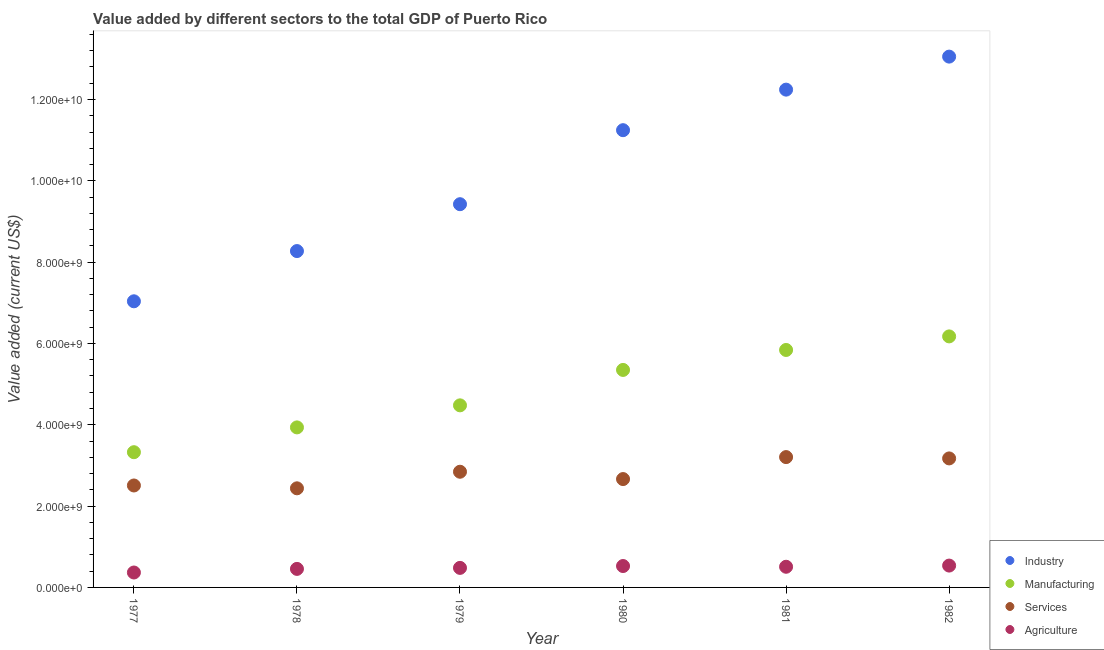What is the value added by services sector in 1979?
Keep it short and to the point. 2.84e+09. Across all years, what is the maximum value added by manufacturing sector?
Keep it short and to the point. 6.17e+09. Across all years, what is the minimum value added by services sector?
Your answer should be compact. 2.44e+09. In which year was the value added by manufacturing sector maximum?
Offer a terse response. 1982. In which year was the value added by industrial sector minimum?
Provide a succinct answer. 1977. What is the total value added by services sector in the graph?
Offer a very short reply. 1.68e+1. What is the difference between the value added by services sector in 1977 and that in 1982?
Your answer should be very brief. -6.66e+08. What is the difference between the value added by manufacturing sector in 1981 and the value added by services sector in 1977?
Offer a very short reply. 3.33e+09. What is the average value added by agricultural sector per year?
Offer a terse response. 4.79e+08. In the year 1978, what is the difference between the value added by industrial sector and value added by agricultural sector?
Provide a succinct answer. 7.82e+09. What is the ratio of the value added by manufacturing sector in 1978 to that in 1982?
Provide a succinct answer. 0.64. What is the difference between the highest and the second highest value added by services sector?
Ensure brevity in your answer.  3.25e+07. What is the difference between the highest and the lowest value added by services sector?
Ensure brevity in your answer.  7.68e+08. In how many years, is the value added by industrial sector greater than the average value added by industrial sector taken over all years?
Offer a terse response. 3. Is the value added by agricultural sector strictly less than the value added by manufacturing sector over the years?
Your answer should be compact. Yes. How many dotlines are there?
Your answer should be compact. 4. Are the values on the major ticks of Y-axis written in scientific E-notation?
Offer a very short reply. Yes. Does the graph contain any zero values?
Offer a terse response. No. Does the graph contain grids?
Keep it short and to the point. No. How are the legend labels stacked?
Give a very brief answer. Vertical. What is the title of the graph?
Provide a succinct answer. Value added by different sectors to the total GDP of Puerto Rico. Does "Corruption" appear as one of the legend labels in the graph?
Provide a succinct answer. No. What is the label or title of the Y-axis?
Offer a terse response. Value added (current US$). What is the Value added (current US$) of Industry in 1977?
Offer a very short reply. 7.04e+09. What is the Value added (current US$) of Manufacturing in 1977?
Your answer should be compact. 3.33e+09. What is the Value added (current US$) of Services in 1977?
Offer a very short reply. 2.51e+09. What is the Value added (current US$) in Agriculture in 1977?
Ensure brevity in your answer.  3.67e+08. What is the Value added (current US$) in Industry in 1978?
Offer a very short reply. 8.27e+09. What is the Value added (current US$) in Manufacturing in 1978?
Give a very brief answer. 3.94e+09. What is the Value added (current US$) in Services in 1978?
Your answer should be compact. 2.44e+09. What is the Value added (current US$) of Agriculture in 1978?
Your response must be concise. 4.56e+08. What is the Value added (current US$) in Industry in 1979?
Make the answer very short. 9.42e+09. What is the Value added (current US$) in Manufacturing in 1979?
Provide a short and direct response. 4.48e+09. What is the Value added (current US$) in Services in 1979?
Your answer should be compact. 2.84e+09. What is the Value added (current US$) in Agriculture in 1979?
Ensure brevity in your answer.  4.81e+08. What is the Value added (current US$) of Industry in 1980?
Make the answer very short. 1.12e+1. What is the Value added (current US$) in Manufacturing in 1980?
Keep it short and to the point. 5.35e+09. What is the Value added (current US$) of Services in 1980?
Provide a short and direct response. 2.66e+09. What is the Value added (current US$) of Agriculture in 1980?
Your response must be concise. 5.26e+08. What is the Value added (current US$) in Industry in 1981?
Keep it short and to the point. 1.22e+1. What is the Value added (current US$) of Manufacturing in 1981?
Your answer should be very brief. 5.84e+09. What is the Value added (current US$) of Services in 1981?
Provide a succinct answer. 3.21e+09. What is the Value added (current US$) in Agriculture in 1981?
Ensure brevity in your answer.  5.08e+08. What is the Value added (current US$) of Industry in 1982?
Offer a terse response. 1.31e+1. What is the Value added (current US$) in Manufacturing in 1982?
Ensure brevity in your answer.  6.17e+09. What is the Value added (current US$) in Services in 1982?
Your answer should be compact. 3.17e+09. What is the Value added (current US$) of Agriculture in 1982?
Offer a very short reply. 5.37e+08. Across all years, what is the maximum Value added (current US$) in Industry?
Ensure brevity in your answer.  1.31e+1. Across all years, what is the maximum Value added (current US$) in Manufacturing?
Provide a succinct answer. 6.17e+09. Across all years, what is the maximum Value added (current US$) of Services?
Offer a terse response. 3.21e+09. Across all years, what is the maximum Value added (current US$) of Agriculture?
Make the answer very short. 5.37e+08. Across all years, what is the minimum Value added (current US$) of Industry?
Offer a very short reply. 7.04e+09. Across all years, what is the minimum Value added (current US$) of Manufacturing?
Offer a terse response. 3.33e+09. Across all years, what is the minimum Value added (current US$) of Services?
Your answer should be very brief. 2.44e+09. Across all years, what is the minimum Value added (current US$) of Agriculture?
Your answer should be very brief. 3.67e+08. What is the total Value added (current US$) of Industry in the graph?
Provide a succinct answer. 6.13e+1. What is the total Value added (current US$) of Manufacturing in the graph?
Keep it short and to the point. 2.91e+1. What is the total Value added (current US$) in Services in the graph?
Make the answer very short. 1.68e+1. What is the total Value added (current US$) in Agriculture in the graph?
Provide a short and direct response. 2.87e+09. What is the difference between the Value added (current US$) in Industry in 1977 and that in 1978?
Give a very brief answer. -1.24e+09. What is the difference between the Value added (current US$) of Manufacturing in 1977 and that in 1978?
Offer a very short reply. -6.10e+08. What is the difference between the Value added (current US$) of Services in 1977 and that in 1978?
Provide a short and direct response. 6.99e+07. What is the difference between the Value added (current US$) in Agriculture in 1977 and that in 1978?
Your answer should be compact. -8.86e+07. What is the difference between the Value added (current US$) in Industry in 1977 and that in 1979?
Offer a terse response. -2.39e+09. What is the difference between the Value added (current US$) in Manufacturing in 1977 and that in 1979?
Provide a succinct answer. -1.15e+09. What is the difference between the Value added (current US$) in Services in 1977 and that in 1979?
Your answer should be compact. -3.38e+08. What is the difference between the Value added (current US$) of Agriculture in 1977 and that in 1979?
Ensure brevity in your answer.  -1.14e+08. What is the difference between the Value added (current US$) of Industry in 1977 and that in 1980?
Provide a succinct answer. -4.21e+09. What is the difference between the Value added (current US$) of Manufacturing in 1977 and that in 1980?
Make the answer very short. -2.02e+09. What is the difference between the Value added (current US$) in Services in 1977 and that in 1980?
Your response must be concise. -1.58e+08. What is the difference between the Value added (current US$) of Agriculture in 1977 and that in 1980?
Keep it short and to the point. -1.59e+08. What is the difference between the Value added (current US$) of Industry in 1977 and that in 1981?
Offer a very short reply. -5.21e+09. What is the difference between the Value added (current US$) of Manufacturing in 1977 and that in 1981?
Your answer should be very brief. -2.51e+09. What is the difference between the Value added (current US$) of Services in 1977 and that in 1981?
Offer a very short reply. -6.98e+08. What is the difference between the Value added (current US$) of Agriculture in 1977 and that in 1981?
Give a very brief answer. -1.41e+08. What is the difference between the Value added (current US$) in Industry in 1977 and that in 1982?
Provide a succinct answer. -6.02e+09. What is the difference between the Value added (current US$) in Manufacturing in 1977 and that in 1982?
Make the answer very short. -2.85e+09. What is the difference between the Value added (current US$) in Services in 1977 and that in 1982?
Offer a very short reply. -6.66e+08. What is the difference between the Value added (current US$) of Agriculture in 1977 and that in 1982?
Keep it short and to the point. -1.70e+08. What is the difference between the Value added (current US$) of Industry in 1978 and that in 1979?
Your answer should be compact. -1.15e+09. What is the difference between the Value added (current US$) of Manufacturing in 1978 and that in 1979?
Ensure brevity in your answer.  -5.42e+08. What is the difference between the Value added (current US$) in Services in 1978 and that in 1979?
Offer a very short reply. -4.08e+08. What is the difference between the Value added (current US$) in Agriculture in 1978 and that in 1979?
Provide a short and direct response. -2.49e+07. What is the difference between the Value added (current US$) of Industry in 1978 and that in 1980?
Give a very brief answer. -2.97e+09. What is the difference between the Value added (current US$) of Manufacturing in 1978 and that in 1980?
Your response must be concise. -1.41e+09. What is the difference between the Value added (current US$) in Services in 1978 and that in 1980?
Ensure brevity in your answer.  -2.28e+08. What is the difference between the Value added (current US$) in Agriculture in 1978 and that in 1980?
Your answer should be very brief. -7.06e+07. What is the difference between the Value added (current US$) in Industry in 1978 and that in 1981?
Make the answer very short. -3.97e+09. What is the difference between the Value added (current US$) in Manufacturing in 1978 and that in 1981?
Offer a terse response. -1.90e+09. What is the difference between the Value added (current US$) of Services in 1978 and that in 1981?
Your answer should be very brief. -7.68e+08. What is the difference between the Value added (current US$) of Agriculture in 1978 and that in 1981?
Offer a terse response. -5.26e+07. What is the difference between the Value added (current US$) in Industry in 1978 and that in 1982?
Offer a terse response. -4.78e+09. What is the difference between the Value added (current US$) in Manufacturing in 1978 and that in 1982?
Offer a very short reply. -2.24e+09. What is the difference between the Value added (current US$) in Services in 1978 and that in 1982?
Offer a very short reply. -7.35e+08. What is the difference between the Value added (current US$) of Agriculture in 1978 and that in 1982?
Make the answer very short. -8.17e+07. What is the difference between the Value added (current US$) in Industry in 1979 and that in 1980?
Give a very brief answer. -1.82e+09. What is the difference between the Value added (current US$) of Manufacturing in 1979 and that in 1980?
Ensure brevity in your answer.  -8.71e+08. What is the difference between the Value added (current US$) of Services in 1979 and that in 1980?
Your answer should be compact. 1.80e+08. What is the difference between the Value added (current US$) of Agriculture in 1979 and that in 1980?
Provide a succinct answer. -4.57e+07. What is the difference between the Value added (current US$) of Industry in 1979 and that in 1981?
Make the answer very short. -2.82e+09. What is the difference between the Value added (current US$) in Manufacturing in 1979 and that in 1981?
Provide a succinct answer. -1.36e+09. What is the difference between the Value added (current US$) in Services in 1979 and that in 1981?
Make the answer very short. -3.60e+08. What is the difference between the Value added (current US$) in Agriculture in 1979 and that in 1981?
Make the answer very short. -2.77e+07. What is the difference between the Value added (current US$) of Industry in 1979 and that in 1982?
Your answer should be very brief. -3.63e+09. What is the difference between the Value added (current US$) in Manufacturing in 1979 and that in 1982?
Make the answer very short. -1.70e+09. What is the difference between the Value added (current US$) of Services in 1979 and that in 1982?
Offer a very short reply. -3.28e+08. What is the difference between the Value added (current US$) in Agriculture in 1979 and that in 1982?
Your response must be concise. -5.68e+07. What is the difference between the Value added (current US$) of Industry in 1980 and that in 1981?
Make the answer very short. -9.97e+08. What is the difference between the Value added (current US$) in Manufacturing in 1980 and that in 1981?
Your answer should be very brief. -4.91e+08. What is the difference between the Value added (current US$) of Services in 1980 and that in 1981?
Your response must be concise. -5.40e+08. What is the difference between the Value added (current US$) in Agriculture in 1980 and that in 1981?
Provide a succinct answer. 1.80e+07. What is the difference between the Value added (current US$) in Industry in 1980 and that in 1982?
Give a very brief answer. -1.81e+09. What is the difference between the Value added (current US$) of Manufacturing in 1980 and that in 1982?
Your answer should be compact. -8.25e+08. What is the difference between the Value added (current US$) of Services in 1980 and that in 1982?
Ensure brevity in your answer.  -5.08e+08. What is the difference between the Value added (current US$) in Agriculture in 1980 and that in 1982?
Offer a very short reply. -1.11e+07. What is the difference between the Value added (current US$) of Industry in 1981 and that in 1982?
Your answer should be compact. -8.12e+08. What is the difference between the Value added (current US$) in Manufacturing in 1981 and that in 1982?
Offer a terse response. -3.34e+08. What is the difference between the Value added (current US$) of Services in 1981 and that in 1982?
Provide a short and direct response. 3.25e+07. What is the difference between the Value added (current US$) of Agriculture in 1981 and that in 1982?
Provide a succinct answer. -2.91e+07. What is the difference between the Value added (current US$) of Industry in 1977 and the Value added (current US$) of Manufacturing in 1978?
Provide a short and direct response. 3.10e+09. What is the difference between the Value added (current US$) of Industry in 1977 and the Value added (current US$) of Services in 1978?
Your response must be concise. 4.60e+09. What is the difference between the Value added (current US$) in Industry in 1977 and the Value added (current US$) in Agriculture in 1978?
Keep it short and to the point. 6.58e+09. What is the difference between the Value added (current US$) in Manufacturing in 1977 and the Value added (current US$) in Services in 1978?
Your answer should be very brief. 8.88e+08. What is the difference between the Value added (current US$) of Manufacturing in 1977 and the Value added (current US$) of Agriculture in 1978?
Give a very brief answer. 2.87e+09. What is the difference between the Value added (current US$) in Services in 1977 and the Value added (current US$) in Agriculture in 1978?
Give a very brief answer. 2.05e+09. What is the difference between the Value added (current US$) in Industry in 1977 and the Value added (current US$) in Manufacturing in 1979?
Give a very brief answer. 2.56e+09. What is the difference between the Value added (current US$) in Industry in 1977 and the Value added (current US$) in Services in 1979?
Offer a very short reply. 4.19e+09. What is the difference between the Value added (current US$) of Industry in 1977 and the Value added (current US$) of Agriculture in 1979?
Ensure brevity in your answer.  6.56e+09. What is the difference between the Value added (current US$) in Manufacturing in 1977 and the Value added (current US$) in Services in 1979?
Keep it short and to the point. 4.81e+08. What is the difference between the Value added (current US$) in Manufacturing in 1977 and the Value added (current US$) in Agriculture in 1979?
Provide a succinct answer. 2.85e+09. What is the difference between the Value added (current US$) of Services in 1977 and the Value added (current US$) of Agriculture in 1979?
Offer a very short reply. 2.03e+09. What is the difference between the Value added (current US$) of Industry in 1977 and the Value added (current US$) of Manufacturing in 1980?
Your answer should be very brief. 1.69e+09. What is the difference between the Value added (current US$) in Industry in 1977 and the Value added (current US$) in Services in 1980?
Offer a very short reply. 4.37e+09. What is the difference between the Value added (current US$) in Industry in 1977 and the Value added (current US$) in Agriculture in 1980?
Offer a very short reply. 6.51e+09. What is the difference between the Value added (current US$) of Manufacturing in 1977 and the Value added (current US$) of Services in 1980?
Provide a short and direct response. 6.61e+08. What is the difference between the Value added (current US$) in Manufacturing in 1977 and the Value added (current US$) in Agriculture in 1980?
Your answer should be very brief. 2.80e+09. What is the difference between the Value added (current US$) of Services in 1977 and the Value added (current US$) of Agriculture in 1980?
Your response must be concise. 1.98e+09. What is the difference between the Value added (current US$) of Industry in 1977 and the Value added (current US$) of Manufacturing in 1981?
Your answer should be very brief. 1.20e+09. What is the difference between the Value added (current US$) in Industry in 1977 and the Value added (current US$) in Services in 1981?
Offer a very short reply. 3.83e+09. What is the difference between the Value added (current US$) in Industry in 1977 and the Value added (current US$) in Agriculture in 1981?
Your answer should be compact. 6.53e+09. What is the difference between the Value added (current US$) of Manufacturing in 1977 and the Value added (current US$) of Services in 1981?
Offer a terse response. 1.20e+08. What is the difference between the Value added (current US$) of Manufacturing in 1977 and the Value added (current US$) of Agriculture in 1981?
Keep it short and to the point. 2.82e+09. What is the difference between the Value added (current US$) in Services in 1977 and the Value added (current US$) in Agriculture in 1981?
Your answer should be compact. 2.00e+09. What is the difference between the Value added (current US$) in Industry in 1977 and the Value added (current US$) in Manufacturing in 1982?
Your answer should be compact. 8.63e+08. What is the difference between the Value added (current US$) of Industry in 1977 and the Value added (current US$) of Services in 1982?
Your answer should be compact. 3.86e+09. What is the difference between the Value added (current US$) in Industry in 1977 and the Value added (current US$) in Agriculture in 1982?
Make the answer very short. 6.50e+09. What is the difference between the Value added (current US$) in Manufacturing in 1977 and the Value added (current US$) in Services in 1982?
Offer a very short reply. 1.53e+08. What is the difference between the Value added (current US$) in Manufacturing in 1977 and the Value added (current US$) in Agriculture in 1982?
Your answer should be very brief. 2.79e+09. What is the difference between the Value added (current US$) of Services in 1977 and the Value added (current US$) of Agriculture in 1982?
Make the answer very short. 1.97e+09. What is the difference between the Value added (current US$) of Industry in 1978 and the Value added (current US$) of Manufacturing in 1979?
Your response must be concise. 3.79e+09. What is the difference between the Value added (current US$) in Industry in 1978 and the Value added (current US$) in Services in 1979?
Offer a terse response. 5.43e+09. What is the difference between the Value added (current US$) of Industry in 1978 and the Value added (current US$) of Agriculture in 1979?
Keep it short and to the point. 7.79e+09. What is the difference between the Value added (current US$) in Manufacturing in 1978 and the Value added (current US$) in Services in 1979?
Offer a very short reply. 1.09e+09. What is the difference between the Value added (current US$) in Manufacturing in 1978 and the Value added (current US$) in Agriculture in 1979?
Keep it short and to the point. 3.46e+09. What is the difference between the Value added (current US$) in Services in 1978 and the Value added (current US$) in Agriculture in 1979?
Provide a succinct answer. 1.96e+09. What is the difference between the Value added (current US$) in Industry in 1978 and the Value added (current US$) in Manufacturing in 1980?
Keep it short and to the point. 2.92e+09. What is the difference between the Value added (current US$) of Industry in 1978 and the Value added (current US$) of Services in 1980?
Give a very brief answer. 5.61e+09. What is the difference between the Value added (current US$) of Industry in 1978 and the Value added (current US$) of Agriculture in 1980?
Ensure brevity in your answer.  7.75e+09. What is the difference between the Value added (current US$) in Manufacturing in 1978 and the Value added (current US$) in Services in 1980?
Your answer should be compact. 1.27e+09. What is the difference between the Value added (current US$) of Manufacturing in 1978 and the Value added (current US$) of Agriculture in 1980?
Your answer should be compact. 3.41e+09. What is the difference between the Value added (current US$) in Services in 1978 and the Value added (current US$) in Agriculture in 1980?
Keep it short and to the point. 1.91e+09. What is the difference between the Value added (current US$) of Industry in 1978 and the Value added (current US$) of Manufacturing in 1981?
Keep it short and to the point. 2.43e+09. What is the difference between the Value added (current US$) in Industry in 1978 and the Value added (current US$) in Services in 1981?
Give a very brief answer. 5.07e+09. What is the difference between the Value added (current US$) of Industry in 1978 and the Value added (current US$) of Agriculture in 1981?
Your answer should be compact. 7.76e+09. What is the difference between the Value added (current US$) of Manufacturing in 1978 and the Value added (current US$) of Services in 1981?
Provide a succinct answer. 7.30e+08. What is the difference between the Value added (current US$) of Manufacturing in 1978 and the Value added (current US$) of Agriculture in 1981?
Keep it short and to the point. 3.43e+09. What is the difference between the Value added (current US$) in Services in 1978 and the Value added (current US$) in Agriculture in 1981?
Provide a succinct answer. 1.93e+09. What is the difference between the Value added (current US$) of Industry in 1978 and the Value added (current US$) of Manufacturing in 1982?
Ensure brevity in your answer.  2.10e+09. What is the difference between the Value added (current US$) in Industry in 1978 and the Value added (current US$) in Services in 1982?
Your answer should be very brief. 5.10e+09. What is the difference between the Value added (current US$) in Industry in 1978 and the Value added (current US$) in Agriculture in 1982?
Give a very brief answer. 7.73e+09. What is the difference between the Value added (current US$) of Manufacturing in 1978 and the Value added (current US$) of Services in 1982?
Give a very brief answer. 7.63e+08. What is the difference between the Value added (current US$) of Manufacturing in 1978 and the Value added (current US$) of Agriculture in 1982?
Offer a terse response. 3.40e+09. What is the difference between the Value added (current US$) in Services in 1978 and the Value added (current US$) in Agriculture in 1982?
Keep it short and to the point. 1.90e+09. What is the difference between the Value added (current US$) of Industry in 1979 and the Value added (current US$) of Manufacturing in 1980?
Offer a very short reply. 4.08e+09. What is the difference between the Value added (current US$) in Industry in 1979 and the Value added (current US$) in Services in 1980?
Provide a succinct answer. 6.76e+09. What is the difference between the Value added (current US$) of Industry in 1979 and the Value added (current US$) of Agriculture in 1980?
Provide a short and direct response. 8.90e+09. What is the difference between the Value added (current US$) in Manufacturing in 1979 and the Value added (current US$) in Services in 1980?
Make the answer very short. 1.81e+09. What is the difference between the Value added (current US$) of Manufacturing in 1979 and the Value added (current US$) of Agriculture in 1980?
Give a very brief answer. 3.95e+09. What is the difference between the Value added (current US$) of Services in 1979 and the Value added (current US$) of Agriculture in 1980?
Make the answer very short. 2.32e+09. What is the difference between the Value added (current US$) of Industry in 1979 and the Value added (current US$) of Manufacturing in 1981?
Ensure brevity in your answer.  3.58e+09. What is the difference between the Value added (current US$) of Industry in 1979 and the Value added (current US$) of Services in 1981?
Give a very brief answer. 6.22e+09. What is the difference between the Value added (current US$) of Industry in 1979 and the Value added (current US$) of Agriculture in 1981?
Your answer should be very brief. 8.92e+09. What is the difference between the Value added (current US$) in Manufacturing in 1979 and the Value added (current US$) in Services in 1981?
Offer a very short reply. 1.27e+09. What is the difference between the Value added (current US$) of Manufacturing in 1979 and the Value added (current US$) of Agriculture in 1981?
Provide a short and direct response. 3.97e+09. What is the difference between the Value added (current US$) in Services in 1979 and the Value added (current US$) in Agriculture in 1981?
Your response must be concise. 2.34e+09. What is the difference between the Value added (current US$) of Industry in 1979 and the Value added (current US$) of Manufacturing in 1982?
Your response must be concise. 3.25e+09. What is the difference between the Value added (current US$) of Industry in 1979 and the Value added (current US$) of Services in 1982?
Offer a terse response. 6.25e+09. What is the difference between the Value added (current US$) in Industry in 1979 and the Value added (current US$) in Agriculture in 1982?
Your answer should be very brief. 8.89e+09. What is the difference between the Value added (current US$) of Manufacturing in 1979 and the Value added (current US$) of Services in 1982?
Your answer should be compact. 1.31e+09. What is the difference between the Value added (current US$) of Manufacturing in 1979 and the Value added (current US$) of Agriculture in 1982?
Offer a very short reply. 3.94e+09. What is the difference between the Value added (current US$) in Services in 1979 and the Value added (current US$) in Agriculture in 1982?
Keep it short and to the point. 2.31e+09. What is the difference between the Value added (current US$) of Industry in 1980 and the Value added (current US$) of Manufacturing in 1981?
Your answer should be very brief. 5.41e+09. What is the difference between the Value added (current US$) of Industry in 1980 and the Value added (current US$) of Services in 1981?
Offer a very short reply. 8.04e+09. What is the difference between the Value added (current US$) in Industry in 1980 and the Value added (current US$) in Agriculture in 1981?
Make the answer very short. 1.07e+1. What is the difference between the Value added (current US$) in Manufacturing in 1980 and the Value added (current US$) in Services in 1981?
Your answer should be compact. 2.14e+09. What is the difference between the Value added (current US$) in Manufacturing in 1980 and the Value added (current US$) in Agriculture in 1981?
Offer a very short reply. 4.84e+09. What is the difference between the Value added (current US$) in Services in 1980 and the Value added (current US$) in Agriculture in 1981?
Provide a succinct answer. 2.16e+09. What is the difference between the Value added (current US$) of Industry in 1980 and the Value added (current US$) of Manufacturing in 1982?
Give a very brief answer. 5.07e+09. What is the difference between the Value added (current US$) in Industry in 1980 and the Value added (current US$) in Services in 1982?
Your answer should be very brief. 8.07e+09. What is the difference between the Value added (current US$) of Industry in 1980 and the Value added (current US$) of Agriculture in 1982?
Give a very brief answer. 1.07e+1. What is the difference between the Value added (current US$) in Manufacturing in 1980 and the Value added (current US$) in Services in 1982?
Provide a short and direct response. 2.18e+09. What is the difference between the Value added (current US$) of Manufacturing in 1980 and the Value added (current US$) of Agriculture in 1982?
Keep it short and to the point. 4.81e+09. What is the difference between the Value added (current US$) in Services in 1980 and the Value added (current US$) in Agriculture in 1982?
Your response must be concise. 2.13e+09. What is the difference between the Value added (current US$) in Industry in 1981 and the Value added (current US$) in Manufacturing in 1982?
Your answer should be very brief. 6.07e+09. What is the difference between the Value added (current US$) of Industry in 1981 and the Value added (current US$) of Services in 1982?
Offer a terse response. 9.07e+09. What is the difference between the Value added (current US$) of Industry in 1981 and the Value added (current US$) of Agriculture in 1982?
Offer a terse response. 1.17e+1. What is the difference between the Value added (current US$) of Manufacturing in 1981 and the Value added (current US$) of Services in 1982?
Provide a succinct answer. 2.67e+09. What is the difference between the Value added (current US$) of Manufacturing in 1981 and the Value added (current US$) of Agriculture in 1982?
Your answer should be very brief. 5.30e+09. What is the difference between the Value added (current US$) in Services in 1981 and the Value added (current US$) in Agriculture in 1982?
Make the answer very short. 2.67e+09. What is the average Value added (current US$) of Industry per year?
Offer a very short reply. 1.02e+1. What is the average Value added (current US$) in Manufacturing per year?
Make the answer very short. 4.85e+09. What is the average Value added (current US$) of Services per year?
Make the answer very short. 2.81e+09. What is the average Value added (current US$) of Agriculture per year?
Your answer should be compact. 4.79e+08. In the year 1977, what is the difference between the Value added (current US$) in Industry and Value added (current US$) in Manufacturing?
Ensure brevity in your answer.  3.71e+09. In the year 1977, what is the difference between the Value added (current US$) in Industry and Value added (current US$) in Services?
Offer a terse response. 4.53e+09. In the year 1977, what is the difference between the Value added (current US$) of Industry and Value added (current US$) of Agriculture?
Keep it short and to the point. 6.67e+09. In the year 1977, what is the difference between the Value added (current US$) of Manufacturing and Value added (current US$) of Services?
Offer a terse response. 8.19e+08. In the year 1977, what is the difference between the Value added (current US$) of Manufacturing and Value added (current US$) of Agriculture?
Your answer should be very brief. 2.96e+09. In the year 1977, what is the difference between the Value added (current US$) in Services and Value added (current US$) in Agriculture?
Keep it short and to the point. 2.14e+09. In the year 1978, what is the difference between the Value added (current US$) of Industry and Value added (current US$) of Manufacturing?
Your response must be concise. 4.34e+09. In the year 1978, what is the difference between the Value added (current US$) in Industry and Value added (current US$) in Services?
Offer a very short reply. 5.83e+09. In the year 1978, what is the difference between the Value added (current US$) in Industry and Value added (current US$) in Agriculture?
Ensure brevity in your answer.  7.82e+09. In the year 1978, what is the difference between the Value added (current US$) in Manufacturing and Value added (current US$) in Services?
Ensure brevity in your answer.  1.50e+09. In the year 1978, what is the difference between the Value added (current US$) of Manufacturing and Value added (current US$) of Agriculture?
Your response must be concise. 3.48e+09. In the year 1978, what is the difference between the Value added (current US$) of Services and Value added (current US$) of Agriculture?
Make the answer very short. 1.98e+09. In the year 1979, what is the difference between the Value added (current US$) of Industry and Value added (current US$) of Manufacturing?
Provide a short and direct response. 4.95e+09. In the year 1979, what is the difference between the Value added (current US$) of Industry and Value added (current US$) of Services?
Make the answer very short. 6.58e+09. In the year 1979, what is the difference between the Value added (current US$) of Industry and Value added (current US$) of Agriculture?
Keep it short and to the point. 8.94e+09. In the year 1979, what is the difference between the Value added (current US$) of Manufacturing and Value added (current US$) of Services?
Your response must be concise. 1.63e+09. In the year 1979, what is the difference between the Value added (current US$) in Manufacturing and Value added (current US$) in Agriculture?
Give a very brief answer. 4.00e+09. In the year 1979, what is the difference between the Value added (current US$) of Services and Value added (current US$) of Agriculture?
Keep it short and to the point. 2.36e+09. In the year 1980, what is the difference between the Value added (current US$) of Industry and Value added (current US$) of Manufacturing?
Offer a terse response. 5.90e+09. In the year 1980, what is the difference between the Value added (current US$) in Industry and Value added (current US$) in Services?
Give a very brief answer. 8.58e+09. In the year 1980, what is the difference between the Value added (current US$) in Industry and Value added (current US$) in Agriculture?
Your response must be concise. 1.07e+1. In the year 1980, what is the difference between the Value added (current US$) in Manufacturing and Value added (current US$) in Services?
Make the answer very short. 2.68e+09. In the year 1980, what is the difference between the Value added (current US$) of Manufacturing and Value added (current US$) of Agriculture?
Provide a short and direct response. 4.82e+09. In the year 1980, what is the difference between the Value added (current US$) of Services and Value added (current US$) of Agriculture?
Provide a succinct answer. 2.14e+09. In the year 1981, what is the difference between the Value added (current US$) of Industry and Value added (current US$) of Manufacturing?
Offer a very short reply. 6.40e+09. In the year 1981, what is the difference between the Value added (current US$) in Industry and Value added (current US$) in Services?
Provide a short and direct response. 9.04e+09. In the year 1981, what is the difference between the Value added (current US$) of Industry and Value added (current US$) of Agriculture?
Your response must be concise. 1.17e+1. In the year 1981, what is the difference between the Value added (current US$) of Manufacturing and Value added (current US$) of Services?
Offer a terse response. 2.63e+09. In the year 1981, what is the difference between the Value added (current US$) in Manufacturing and Value added (current US$) in Agriculture?
Your answer should be very brief. 5.33e+09. In the year 1981, what is the difference between the Value added (current US$) in Services and Value added (current US$) in Agriculture?
Your answer should be very brief. 2.70e+09. In the year 1982, what is the difference between the Value added (current US$) in Industry and Value added (current US$) in Manufacturing?
Offer a terse response. 6.88e+09. In the year 1982, what is the difference between the Value added (current US$) in Industry and Value added (current US$) in Services?
Offer a very short reply. 9.88e+09. In the year 1982, what is the difference between the Value added (current US$) of Industry and Value added (current US$) of Agriculture?
Keep it short and to the point. 1.25e+1. In the year 1982, what is the difference between the Value added (current US$) in Manufacturing and Value added (current US$) in Services?
Ensure brevity in your answer.  3.00e+09. In the year 1982, what is the difference between the Value added (current US$) in Manufacturing and Value added (current US$) in Agriculture?
Offer a terse response. 5.64e+09. In the year 1982, what is the difference between the Value added (current US$) of Services and Value added (current US$) of Agriculture?
Your answer should be compact. 2.64e+09. What is the ratio of the Value added (current US$) in Industry in 1977 to that in 1978?
Provide a short and direct response. 0.85. What is the ratio of the Value added (current US$) in Manufacturing in 1977 to that in 1978?
Provide a short and direct response. 0.84. What is the ratio of the Value added (current US$) in Services in 1977 to that in 1978?
Offer a very short reply. 1.03. What is the ratio of the Value added (current US$) of Agriculture in 1977 to that in 1978?
Make the answer very short. 0.81. What is the ratio of the Value added (current US$) in Industry in 1977 to that in 1979?
Offer a very short reply. 0.75. What is the ratio of the Value added (current US$) in Manufacturing in 1977 to that in 1979?
Your response must be concise. 0.74. What is the ratio of the Value added (current US$) in Services in 1977 to that in 1979?
Provide a succinct answer. 0.88. What is the ratio of the Value added (current US$) of Agriculture in 1977 to that in 1979?
Offer a very short reply. 0.76. What is the ratio of the Value added (current US$) in Industry in 1977 to that in 1980?
Your answer should be very brief. 0.63. What is the ratio of the Value added (current US$) in Manufacturing in 1977 to that in 1980?
Keep it short and to the point. 0.62. What is the ratio of the Value added (current US$) in Services in 1977 to that in 1980?
Give a very brief answer. 0.94. What is the ratio of the Value added (current US$) of Agriculture in 1977 to that in 1980?
Your response must be concise. 0.7. What is the ratio of the Value added (current US$) in Industry in 1977 to that in 1981?
Your answer should be compact. 0.57. What is the ratio of the Value added (current US$) of Manufacturing in 1977 to that in 1981?
Make the answer very short. 0.57. What is the ratio of the Value added (current US$) in Services in 1977 to that in 1981?
Provide a short and direct response. 0.78. What is the ratio of the Value added (current US$) of Agriculture in 1977 to that in 1981?
Offer a very short reply. 0.72. What is the ratio of the Value added (current US$) of Industry in 1977 to that in 1982?
Your response must be concise. 0.54. What is the ratio of the Value added (current US$) of Manufacturing in 1977 to that in 1982?
Your response must be concise. 0.54. What is the ratio of the Value added (current US$) in Services in 1977 to that in 1982?
Your response must be concise. 0.79. What is the ratio of the Value added (current US$) in Agriculture in 1977 to that in 1982?
Your answer should be very brief. 0.68. What is the ratio of the Value added (current US$) in Industry in 1978 to that in 1979?
Provide a succinct answer. 0.88. What is the ratio of the Value added (current US$) of Manufacturing in 1978 to that in 1979?
Offer a terse response. 0.88. What is the ratio of the Value added (current US$) of Services in 1978 to that in 1979?
Offer a terse response. 0.86. What is the ratio of the Value added (current US$) in Agriculture in 1978 to that in 1979?
Offer a very short reply. 0.95. What is the ratio of the Value added (current US$) of Industry in 1978 to that in 1980?
Keep it short and to the point. 0.74. What is the ratio of the Value added (current US$) in Manufacturing in 1978 to that in 1980?
Offer a very short reply. 0.74. What is the ratio of the Value added (current US$) of Services in 1978 to that in 1980?
Give a very brief answer. 0.91. What is the ratio of the Value added (current US$) of Agriculture in 1978 to that in 1980?
Your response must be concise. 0.87. What is the ratio of the Value added (current US$) in Industry in 1978 to that in 1981?
Offer a terse response. 0.68. What is the ratio of the Value added (current US$) of Manufacturing in 1978 to that in 1981?
Ensure brevity in your answer.  0.67. What is the ratio of the Value added (current US$) of Services in 1978 to that in 1981?
Your answer should be compact. 0.76. What is the ratio of the Value added (current US$) in Agriculture in 1978 to that in 1981?
Offer a terse response. 0.9. What is the ratio of the Value added (current US$) of Industry in 1978 to that in 1982?
Your response must be concise. 0.63. What is the ratio of the Value added (current US$) in Manufacturing in 1978 to that in 1982?
Give a very brief answer. 0.64. What is the ratio of the Value added (current US$) of Services in 1978 to that in 1982?
Keep it short and to the point. 0.77. What is the ratio of the Value added (current US$) in Agriculture in 1978 to that in 1982?
Keep it short and to the point. 0.85. What is the ratio of the Value added (current US$) of Industry in 1979 to that in 1980?
Offer a terse response. 0.84. What is the ratio of the Value added (current US$) of Manufacturing in 1979 to that in 1980?
Your response must be concise. 0.84. What is the ratio of the Value added (current US$) in Services in 1979 to that in 1980?
Keep it short and to the point. 1.07. What is the ratio of the Value added (current US$) of Agriculture in 1979 to that in 1980?
Ensure brevity in your answer.  0.91. What is the ratio of the Value added (current US$) in Industry in 1979 to that in 1981?
Ensure brevity in your answer.  0.77. What is the ratio of the Value added (current US$) of Manufacturing in 1979 to that in 1981?
Your answer should be very brief. 0.77. What is the ratio of the Value added (current US$) in Services in 1979 to that in 1981?
Give a very brief answer. 0.89. What is the ratio of the Value added (current US$) of Agriculture in 1979 to that in 1981?
Provide a succinct answer. 0.95. What is the ratio of the Value added (current US$) of Industry in 1979 to that in 1982?
Your response must be concise. 0.72. What is the ratio of the Value added (current US$) in Manufacturing in 1979 to that in 1982?
Your answer should be compact. 0.73. What is the ratio of the Value added (current US$) in Services in 1979 to that in 1982?
Your response must be concise. 0.9. What is the ratio of the Value added (current US$) in Agriculture in 1979 to that in 1982?
Your answer should be very brief. 0.89. What is the ratio of the Value added (current US$) of Industry in 1980 to that in 1981?
Ensure brevity in your answer.  0.92. What is the ratio of the Value added (current US$) of Manufacturing in 1980 to that in 1981?
Give a very brief answer. 0.92. What is the ratio of the Value added (current US$) in Services in 1980 to that in 1981?
Make the answer very short. 0.83. What is the ratio of the Value added (current US$) of Agriculture in 1980 to that in 1981?
Your response must be concise. 1.04. What is the ratio of the Value added (current US$) of Industry in 1980 to that in 1982?
Give a very brief answer. 0.86. What is the ratio of the Value added (current US$) of Manufacturing in 1980 to that in 1982?
Provide a succinct answer. 0.87. What is the ratio of the Value added (current US$) in Services in 1980 to that in 1982?
Your answer should be compact. 0.84. What is the ratio of the Value added (current US$) of Agriculture in 1980 to that in 1982?
Provide a succinct answer. 0.98. What is the ratio of the Value added (current US$) of Industry in 1981 to that in 1982?
Your response must be concise. 0.94. What is the ratio of the Value added (current US$) of Manufacturing in 1981 to that in 1982?
Give a very brief answer. 0.95. What is the ratio of the Value added (current US$) in Services in 1981 to that in 1982?
Make the answer very short. 1.01. What is the ratio of the Value added (current US$) of Agriculture in 1981 to that in 1982?
Make the answer very short. 0.95. What is the difference between the highest and the second highest Value added (current US$) in Industry?
Your answer should be compact. 8.12e+08. What is the difference between the highest and the second highest Value added (current US$) in Manufacturing?
Your answer should be compact. 3.34e+08. What is the difference between the highest and the second highest Value added (current US$) of Services?
Make the answer very short. 3.25e+07. What is the difference between the highest and the second highest Value added (current US$) of Agriculture?
Offer a terse response. 1.11e+07. What is the difference between the highest and the lowest Value added (current US$) of Industry?
Offer a very short reply. 6.02e+09. What is the difference between the highest and the lowest Value added (current US$) in Manufacturing?
Your answer should be very brief. 2.85e+09. What is the difference between the highest and the lowest Value added (current US$) in Services?
Offer a very short reply. 7.68e+08. What is the difference between the highest and the lowest Value added (current US$) in Agriculture?
Your response must be concise. 1.70e+08. 